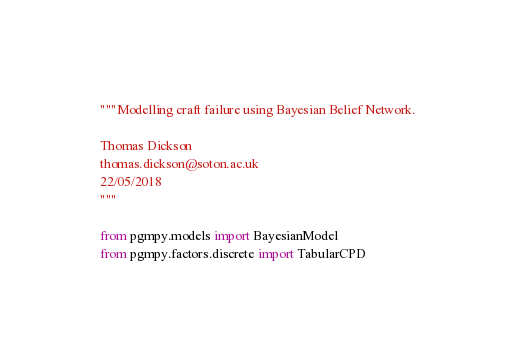<code> <loc_0><loc_0><loc_500><loc_500><_Python_>"""Modelling craft failure using Bayesian Belief Network.

Thomas Dickson
thomas.dickson@soton.ac.uk
22/05/2018
"""

from pgmpy.models import BayesianModel
from pgmpy.factors.discrete import TabularCPD</code> 